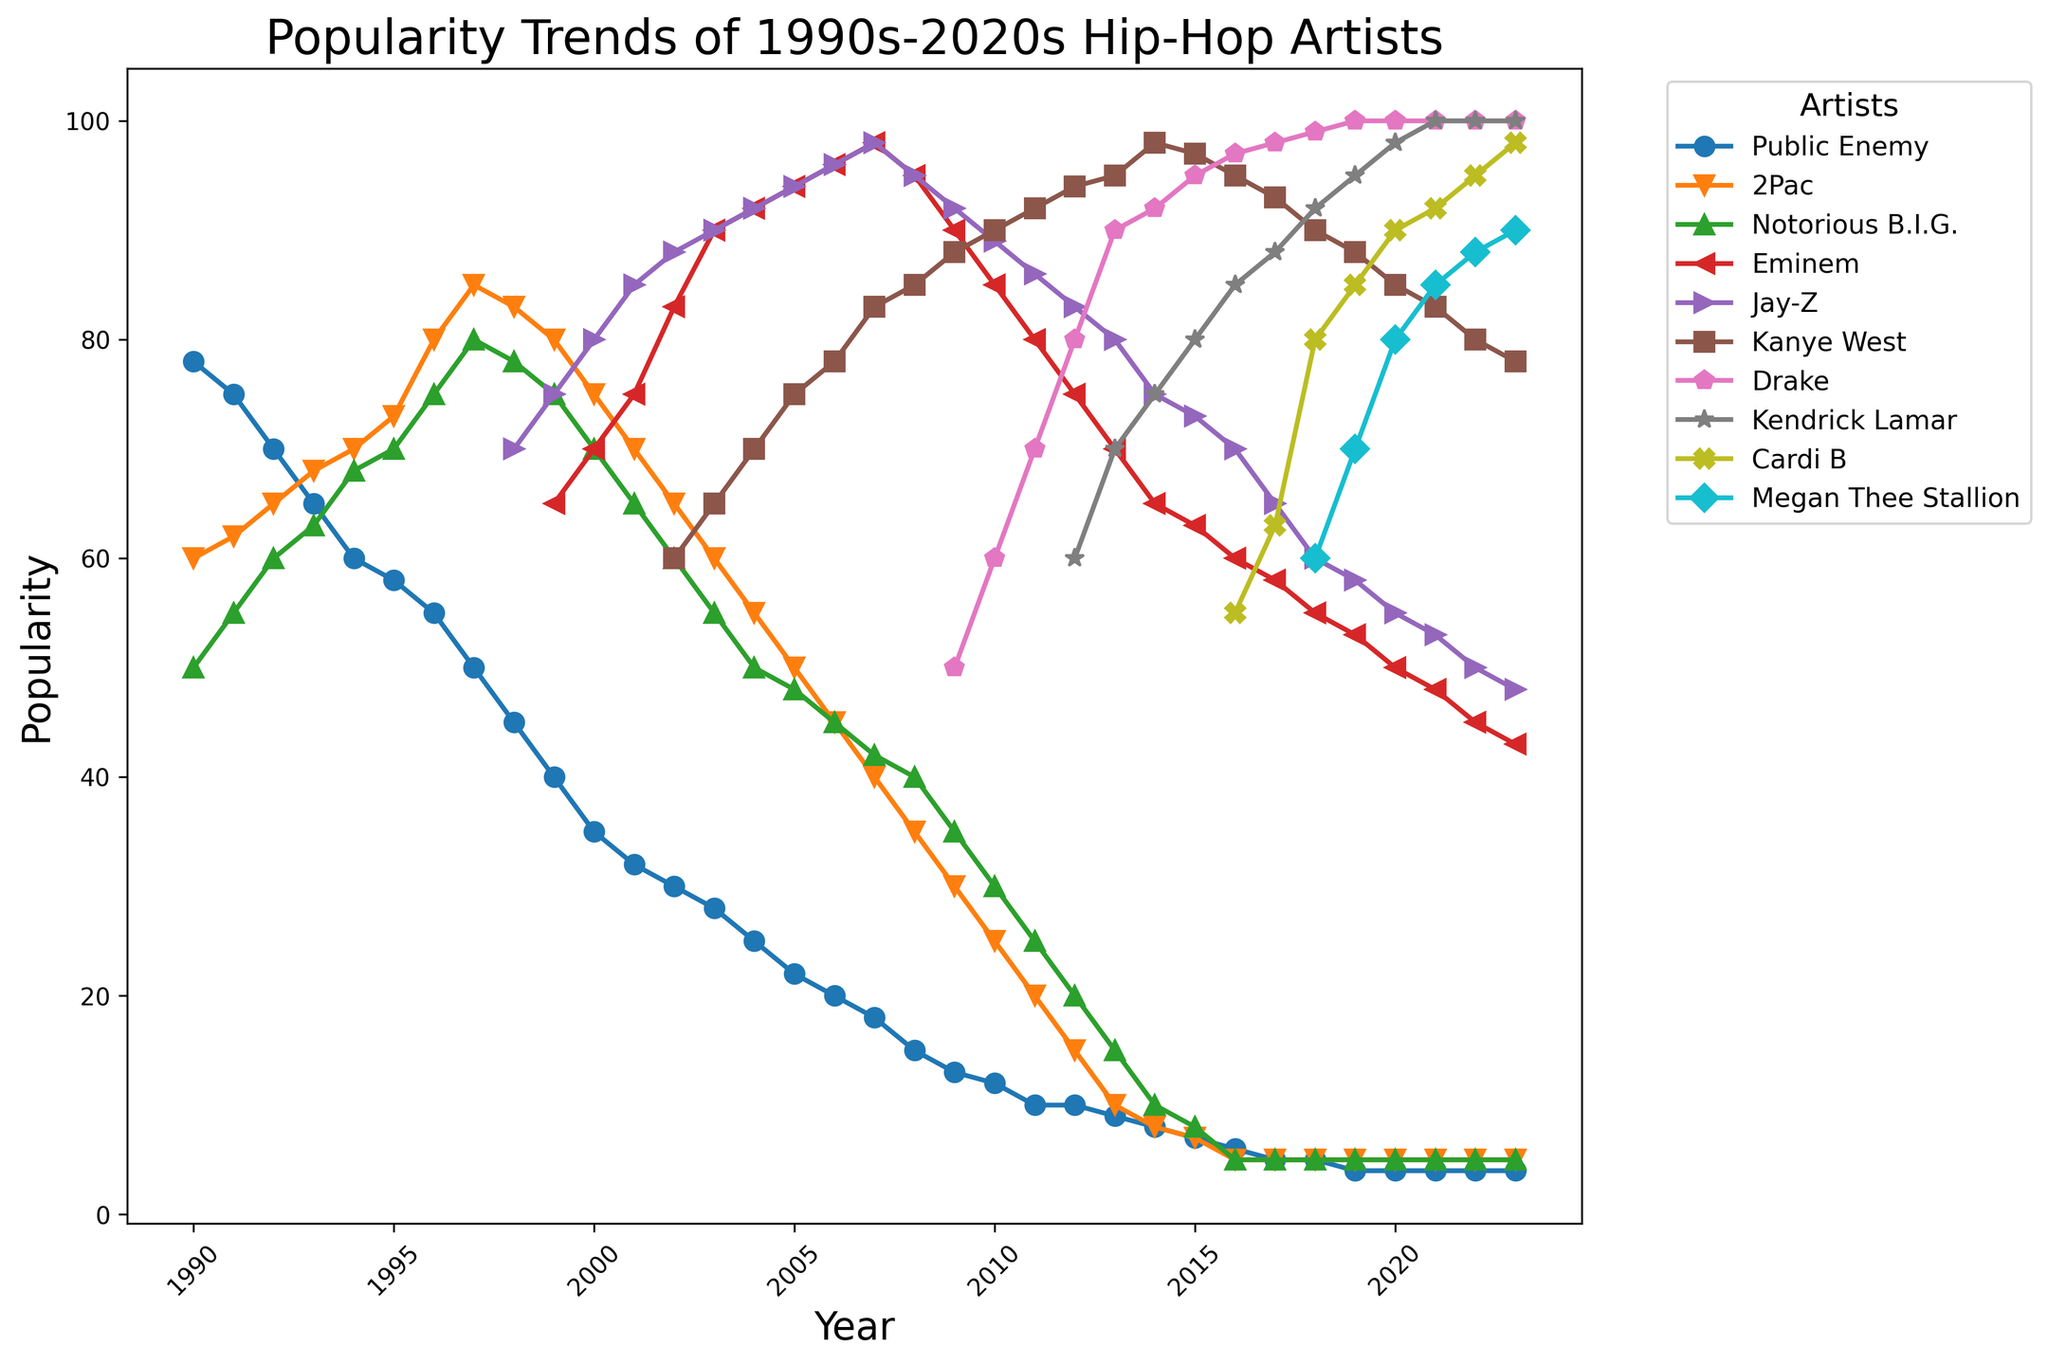What is the popularity trend for Public Enemy from 1990 to 2023? To determine the trend, observe the line representing Public Enemy on the chart. The line starts at a high point in 1990 and gradually decreases over time, showcasing a decline in popularity.
Answer: Declining Which artist had the highest popularity in 2023? Look at the endpoints of each line for 2023 and identify which one is at the highest position. The artist with the line ending at the highest point has the highest popularity.
Answer: Drake Who had a higher popularity in 1997, Public Enemy or Kanye West? Check the points corresponding to 1997 for both Public Enemy and Kanye West. Since Kanye West does not have data in 1997, only Public Enemy's point is available.
Answer: Public Enemy Between which years did 2Pac experience the highest increase in popularity? Observe the line for 2Pac and identify the steepest upward slope. The steepest slope is between 1995 and 1996.
Answer: 1995-1996 Compare the popularity of Eminem and Kendrick Lamar in 2015. Which one is higher? Locate 2015 on the x-axis and compare the y-values of Eminem and Kendrick Lamar. Eminem’s popularity is higher as indicated by the higher y-value.
Answer: Eminem Which artist has maintained the highest consistent popularity from 2018 to 2023? Identify the lines from 2018 to 2023 and find the one that stays closest to the top, indicating consistent high popularity. Consistent high values are seen for Drake.
Answer: Drake In what year did Jay-Z reach his peak popularity? Follow the line for Jay-Z and identify the year where the line reaches its highest point.
Answer: 2007 How does Public Enemy's popularity in 2010 compare to Cardi B's popularity in 2020? Find and compare the points for Public Enemy in 2010 and Cardi B in 2020. Cardi B in 2020 is at a higher y-value than Public Enemy in 2010.
Answer: Cardi B in 2020 is higher Estimate the average popularity of Kanye West from 2004 to 2010. Identify the y-values for Kanye West from 2004 to 2010, then sum them and divide by the number of years (7). Popularities are 70, 75, 78, 83, 85, 90, 88. The average is (70+75+78+83+85+90+88)/7 = 81.2857.
Answer: ~81.3 Who experienced a sharper decline in popularity between 2000 and 2003, Public Enemy or Notorious B.I.G.? Compare the slopes of the lines for Public Enemy and Notorious B.I.G. between 2000 and 2003. Public Enemy's line has a gentler decline compared to the steeper decline of the Notorious B.I.G..
Answer: Notorious B.I.G 